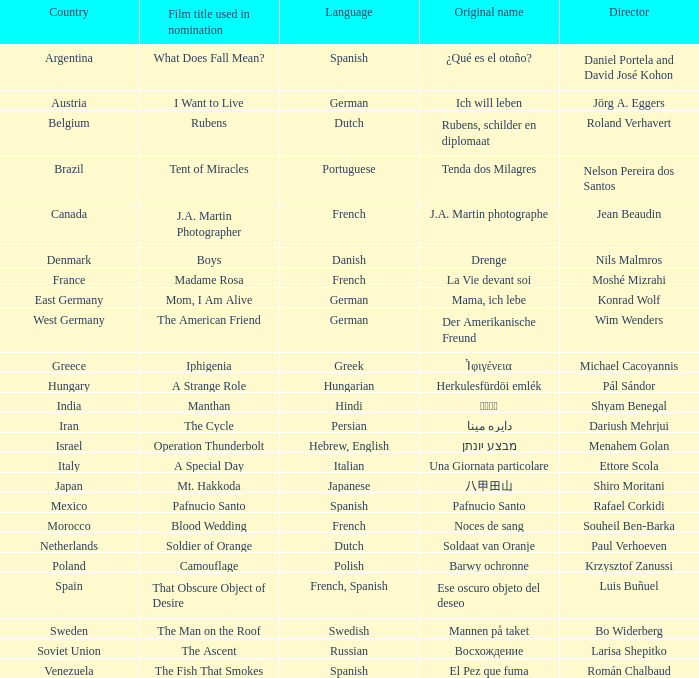Which filmmaker is from italy? Ettore Scola. 